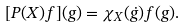Convert formula to latex. <formula><loc_0><loc_0><loc_500><loc_500>[ P ( X ) f ] ( g ) = \chi _ { X } ( \dot { g } ) f ( g ) .</formula> 